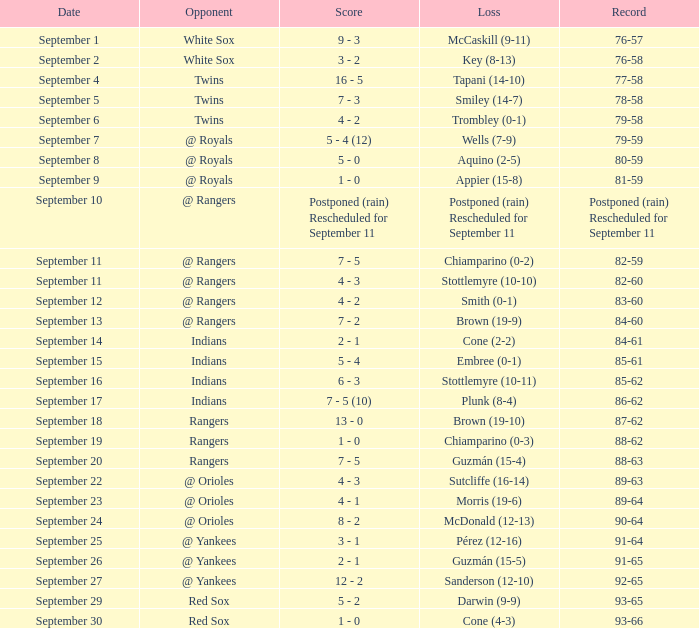What is the score from September 15 that has the Indians as the opponent? 5 - 4. I'm looking to parse the entire table for insights. Could you assist me with that? {'header': ['Date', 'Opponent', 'Score', 'Loss', 'Record'], 'rows': [['September 1', 'White Sox', '9 - 3', 'McCaskill (9-11)', '76-57'], ['September 2', 'White Sox', '3 - 2', 'Key (8-13)', '76-58'], ['September 4', 'Twins', '16 - 5', 'Tapani (14-10)', '77-58'], ['September 5', 'Twins', '7 - 3', 'Smiley (14-7)', '78-58'], ['September 6', 'Twins', '4 - 2', 'Trombley (0-1)', '79-58'], ['September 7', '@ Royals', '5 - 4 (12)', 'Wells (7-9)', '79-59'], ['September 8', '@ Royals', '5 - 0', 'Aquino (2-5)', '80-59'], ['September 9', '@ Royals', '1 - 0', 'Appier (15-8)', '81-59'], ['September 10', '@ Rangers', 'Postponed (rain) Rescheduled for September 11', 'Postponed (rain) Rescheduled for September 11', 'Postponed (rain) Rescheduled for September 11'], ['September 11', '@ Rangers', '7 - 5', 'Chiamparino (0-2)', '82-59'], ['September 11', '@ Rangers', '4 - 3', 'Stottlemyre (10-10)', '82-60'], ['September 12', '@ Rangers', '4 - 2', 'Smith (0-1)', '83-60'], ['September 13', '@ Rangers', '7 - 2', 'Brown (19-9)', '84-60'], ['September 14', 'Indians', '2 - 1', 'Cone (2-2)', '84-61'], ['September 15', 'Indians', '5 - 4', 'Embree (0-1)', '85-61'], ['September 16', 'Indians', '6 - 3', 'Stottlemyre (10-11)', '85-62'], ['September 17', 'Indians', '7 - 5 (10)', 'Plunk (8-4)', '86-62'], ['September 18', 'Rangers', '13 - 0', 'Brown (19-10)', '87-62'], ['September 19', 'Rangers', '1 - 0', 'Chiamparino (0-3)', '88-62'], ['September 20', 'Rangers', '7 - 5', 'Guzmán (15-4)', '88-63'], ['September 22', '@ Orioles', '4 - 3', 'Sutcliffe (16-14)', '89-63'], ['September 23', '@ Orioles', '4 - 1', 'Morris (19-6)', '89-64'], ['September 24', '@ Orioles', '8 - 2', 'McDonald (12-13)', '90-64'], ['September 25', '@ Yankees', '3 - 1', 'Pérez (12-16)', '91-64'], ['September 26', '@ Yankees', '2 - 1', 'Guzmán (15-5)', '91-65'], ['September 27', '@ Yankees', '12 - 2', 'Sanderson (12-10)', '92-65'], ['September 29', 'Red Sox', '5 - 2', 'Darwin (9-9)', '93-65'], ['September 30', 'Red Sox', '1 - 0', 'Cone (4-3)', '93-66']]} 